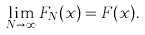Convert formula to latex. <formula><loc_0><loc_0><loc_500><loc_500>\lim _ { N \rightarrow \infty } F _ { N } ( x ) = F ( x ) .</formula> 